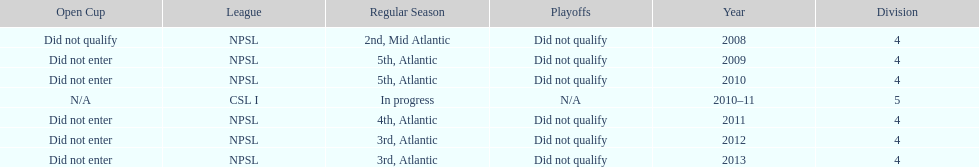For how many years did they fail to qualify for the playoffs? 6. 